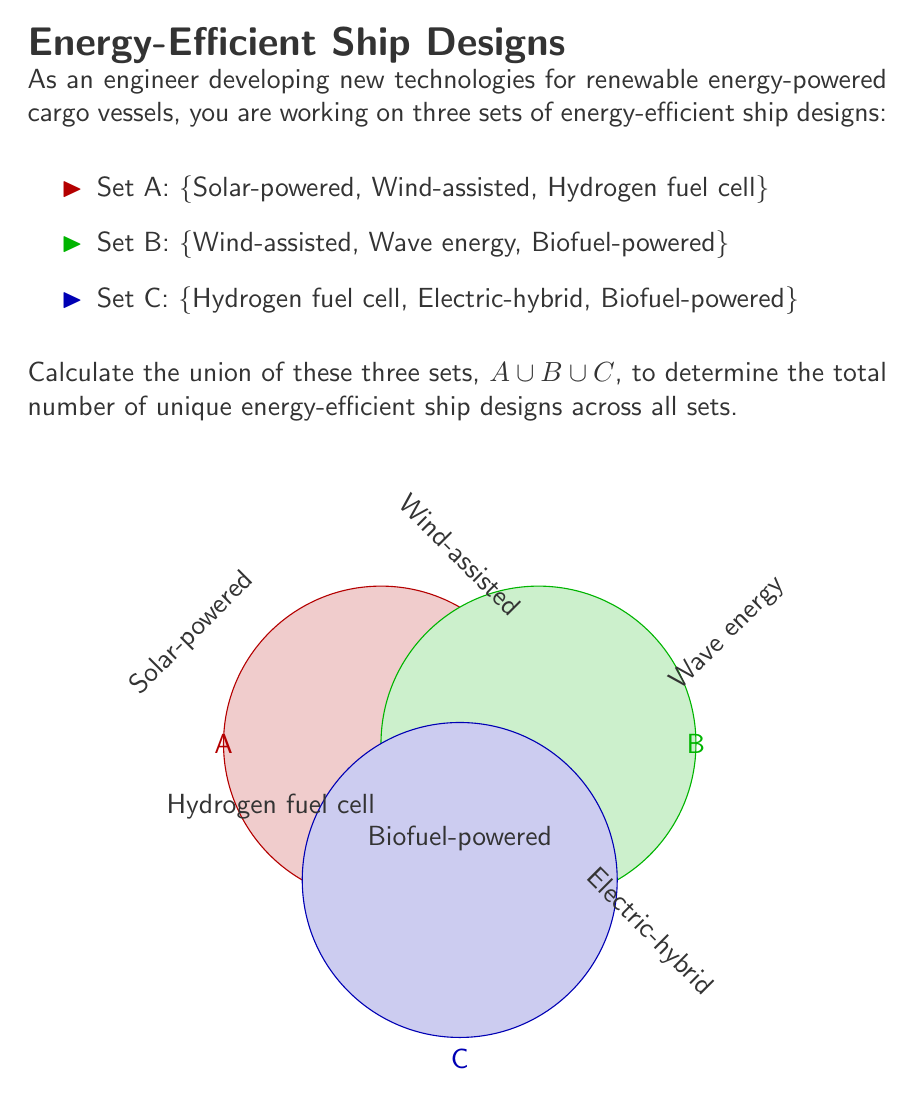Can you solve this math problem? To find the union of sets A, B, and C, we need to list all unique elements from all three sets. Let's approach this step-by-step:

1. List all elements from each set:
   Set A: {Solar-powered, Wind-assisted, Hydrogen fuel cell}
   Set B: {Wind-assisted, Wave energy, Biofuel-powered}
   Set C: {Hydrogen fuel cell, Electric-hybrid, Biofuel-powered}

2. Identify unique elements:
   - Solar-powered (from A)
   - Wind-assisted (from A and B)
   - Hydrogen fuel cell (from A and C)
   - Wave energy (from B)
   - Biofuel-powered (from B and C)
   - Electric-hybrid (from C)

3. Count the unique elements:
   There are 6 unique elements in total.

4. Express the union mathematically:
   $$A \cup B \cup C = \{Solar-powered, Wind-assisted, Hydrogen fuel cell, Wave energy, Biofuel-powered, Electric-hybrid\}$$

5. Calculate the cardinality of the union:
   $$|A \cup B \cup C| = 6$$

The union of these three sets contains all unique energy-efficient ship designs from all sets, eliminating any duplicates.
Answer: $|A \cup B \cup C| = 6$ 